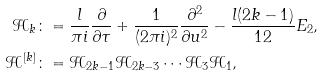<formula> <loc_0><loc_0><loc_500><loc_500>\mathcal { H } _ { k } & \colon = \frac { l } { \pi i } \frac { \partial } { \partial \tau } + \frac { 1 } { ( 2 \pi i ) ^ { 2 } } \frac { \partial ^ { 2 } } { \partial u ^ { 2 } } - \frac { l ( 2 k - 1 ) } { 1 2 } E _ { 2 } , \\ \mathcal { H } ^ { [ k ] } & \colon = \mathcal { H } _ { 2 k - 1 } \mathcal { H } _ { 2 k - 3 } \cdots \mathcal { H } _ { 3 } \mathcal { H } _ { 1 } ,</formula> 